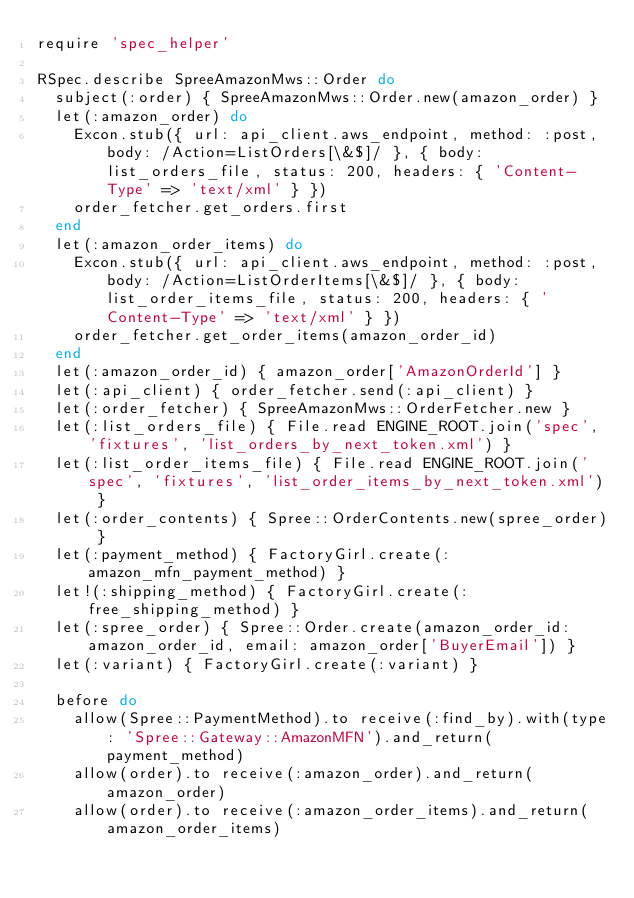<code> <loc_0><loc_0><loc_500><loc_500><_Ruby_>require 'spec_helper'

RSpec.describe SpreeAmazonMws::Order do
  subject(:order) { SpreeAmazonMws::Order.new(amazon_order) }
  let(:amazon_order) do
    Excon.stub({ url: api_client.aws_endpoint, method: :post, body: /Action=ListOrders[\&$]/ }, { body: list_orders_file, status: 200, headers: { 'Content-Type' => 'text/xml' } })
    order_fetcher.get_orders.first
  end
  let(:amazon_order_items) do
    Excon.stub({ url: api_client.aws_endpoint, method: :post, body: /Action=ListOrderItems[\&$]/ }, { body: list_order_items_file, status: 200, headers: { 'Content-Type' => 'text/xml' } })
    order_fetcher.get_order_items(amazon_order_id)
  end
  let(:amazon_order_id) { amazon_order['AmazonOrderId'] }
  let(:api_client) { order_fetcher.send(:api_client) }
  let(:order_fetcher) { SpreeAmazonMws::OrderFetcher.new }
  let(:list_orders_file) { File.read ENGINE_ROOT.join('spec', 'fixtures', 'list_orders_by_next_token.xml') }
  let(:list_order_items_file) { File.read ENGINE_ROOT.join('spec', 'fixtures', 'list_order_items_by_next_token.xml') }
  let(:order_contents) { Spree::OrderContents.new(spree_order) }
  let(:payment_method) { FactoryGirl.create(:amazon_mfn_payment_method) }
  let!(:shipping_method) { FactoryGirl.create(:free_shipping_method) }
  let(:spree_order) { Spree::Order.create(amazon_order_id: amazon_order_id, email: amazon_order['BuyerEmail']) }
  let(:variant) { FactoryGirl.create(:variant) }

  before do
    allow(Spree::PaymentMethod).to receive(:find_by).with(type: 'Spree::Gateway::AmazonMFN').and_return(payment_method)
    allow(order).to receive(:amazon_order).and_return(amazon_order)
    allow(order).to receive(:amazon_order_items).and_return(amazon_order_items)</code> 